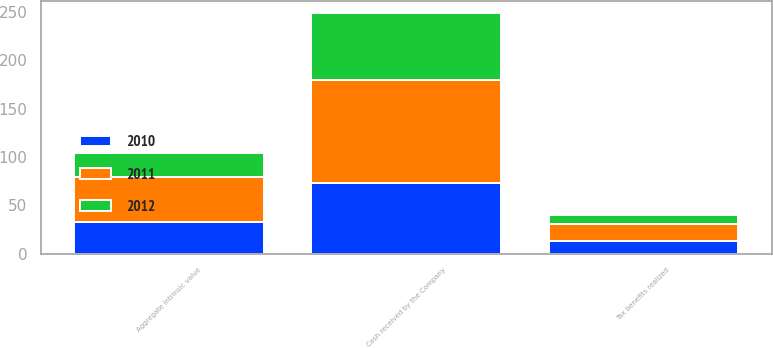Convert chart. <chart><loc_0><loc_0><loc_500><loc_500><stacked_bar_chart><ecel><fcel>Cash received by the Company<fcel>Tax benefits realized<fcel>Aggregate intrinsic value<nl><fcel>2012<fcel>69.4<fcel>9.7<fcel>25.3<nl><fcel>2011<fcel>106.1<fcel>17.7<fcel>45.5<nl><fcel>2010<fcel>73.7<fcel>13<fcel>33.4<nl></chart> 